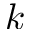<formula> <loc_0><loc_0><loc_500><loc_500>k</formula> 